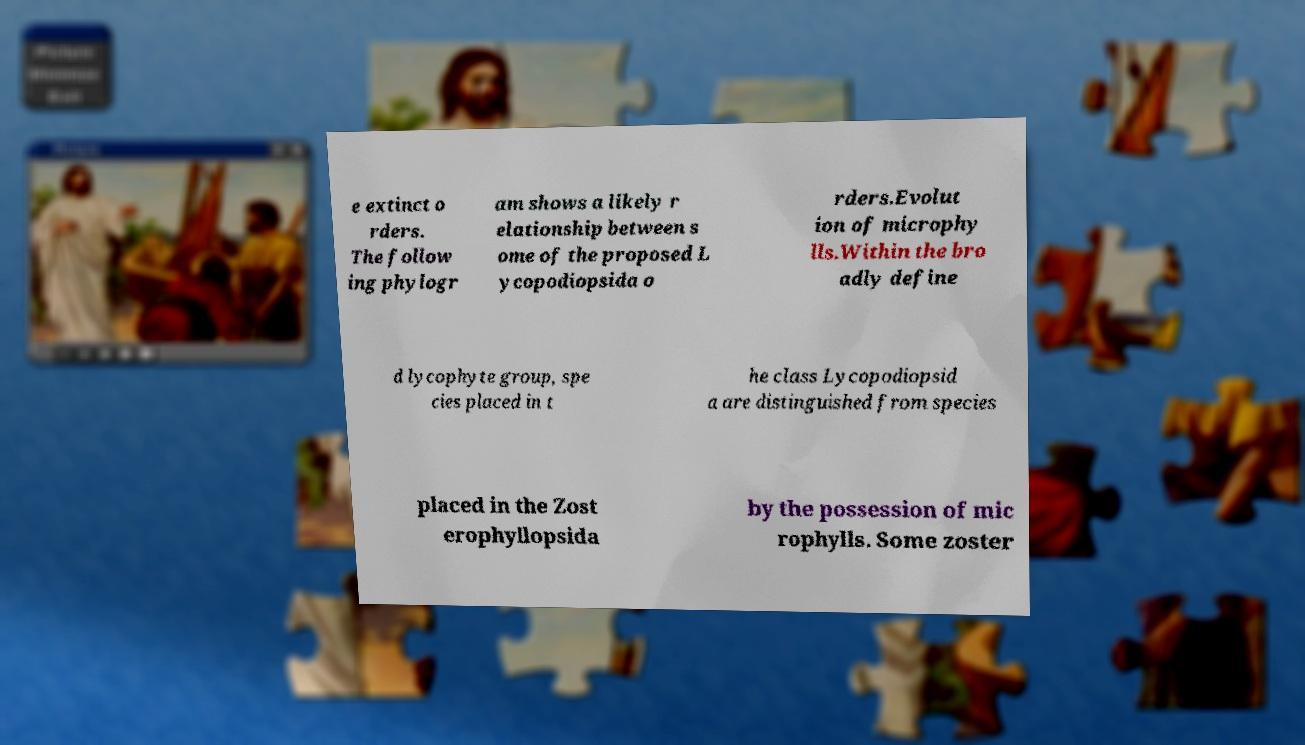Could you assist in decoding the text presented in this image and type it out clearly? e extinct o rders. The follow ing phylogr am shows a likely r elationship between s ome of the proposed L ycopodiopsida o rders.Evolut ion of microphy lls.Within the bro adly define d lycophyte group, spe cies placed in t he class Lycopodiopsid a are distinguished from species placed in the Zost erophyllopsida by the possession of mic rophylls. Some zoster 